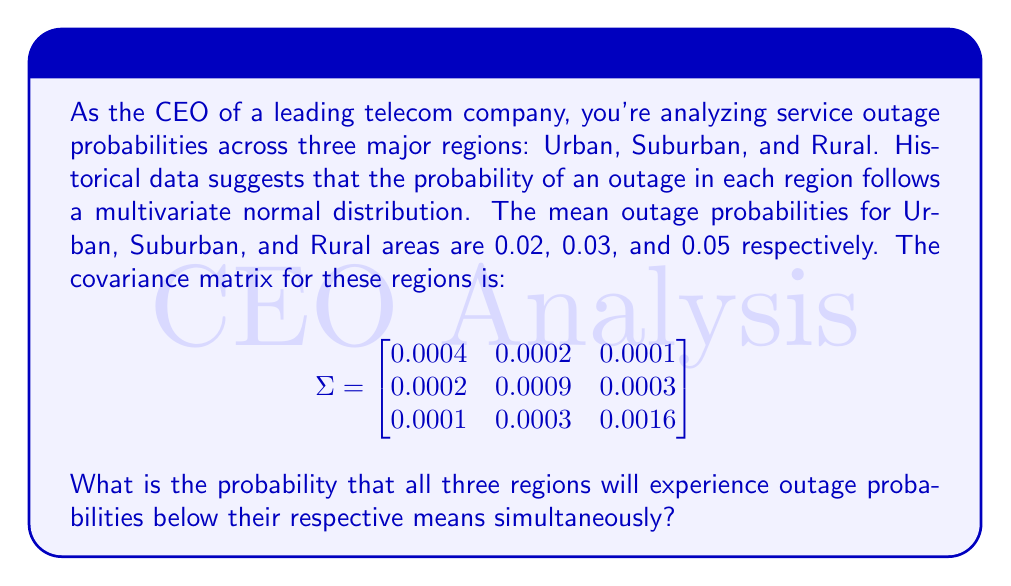Show me your answer to this math problem. To solve this problem, we need to use the properties of the multivariate normal distribution. Let's approach this step-by-step:

1) We are dealing with a trivariate normal distribution, where:
   $\mu = (0.02, 0.03, 0.05)$ and $\Sigma$ is given in the question.

2) We need to find $P(X_1 < 0.02, X_2 < 0.03, X_3 < 0.05)$, where $X_1$, $X_2$, and $X_3$ represent the outage probabilities for Urban, Suburban, and Rural areas respectively.

3) For a multivariate normal distribution, the probability that all variables are simultaneously less than their means is always 0.125 (1/8), regardless of the covariance matrix. This is because the multivariate normal distribution is symmetric around its mean vector.

4) This property stems from the fact that in a multivariate normal distribution, each quadrant (or octant in 3D) contains an equal proportion of the probability mass.

5) In our 3D case, we have 8 octants, and we're interested in the octant where all three variables are below their respective means.

Therefore, the probability that all three regions will experience outage probabilities below their respective means simultaneously is 0.125 or 1/8.

This result is particularly useful for quick estimations in complex systems, as it doesn't require complex calculations of the multivariate normal cumulative distribution function.
Answer: 0.125 